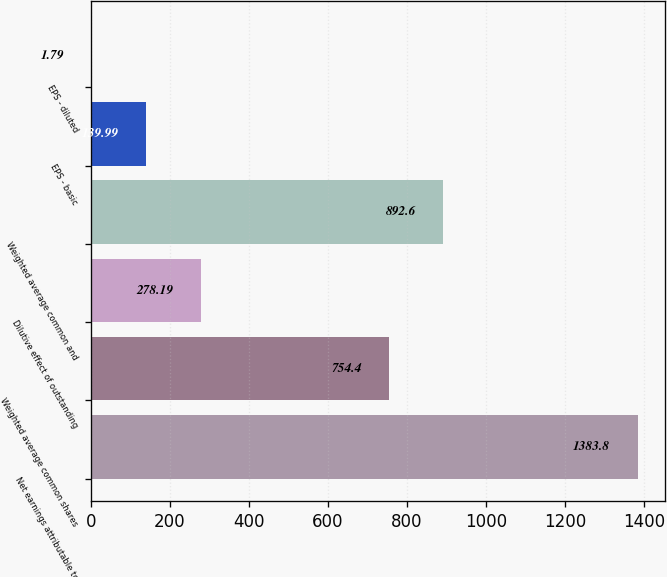<chart> <loc_0><loc_0><loc_500><loc_500><bar_chart><fcel>Net earnings attributable to<fcel>Weighted average common shares<fcel>Dilutive effect of outstanding<fcel>Weighted average common and<fcel>EPS - basic<fcel>EPS - diluted<nl><fcel>1383.8<fcel>754.4<fcel>278.19<fcel>892.6<fcel>139.99<fcel>1.79<nl></chart> 